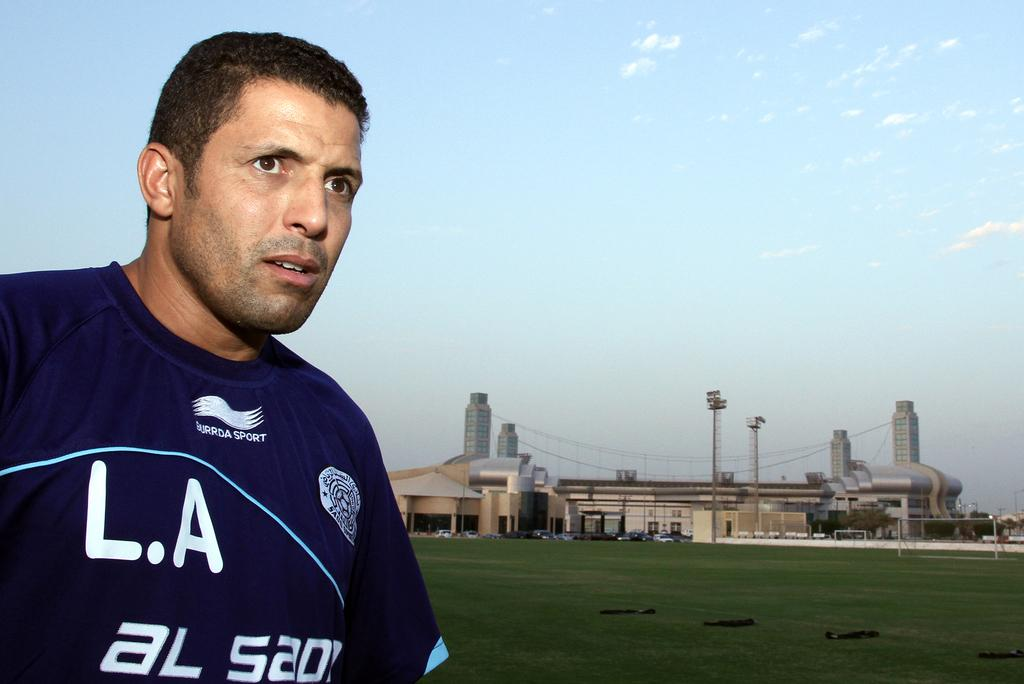<image>
Create a compact narrative representing the image presented. A man wearing a blue top with L.A on it stands with a large sporting complex behind him in the distance. 